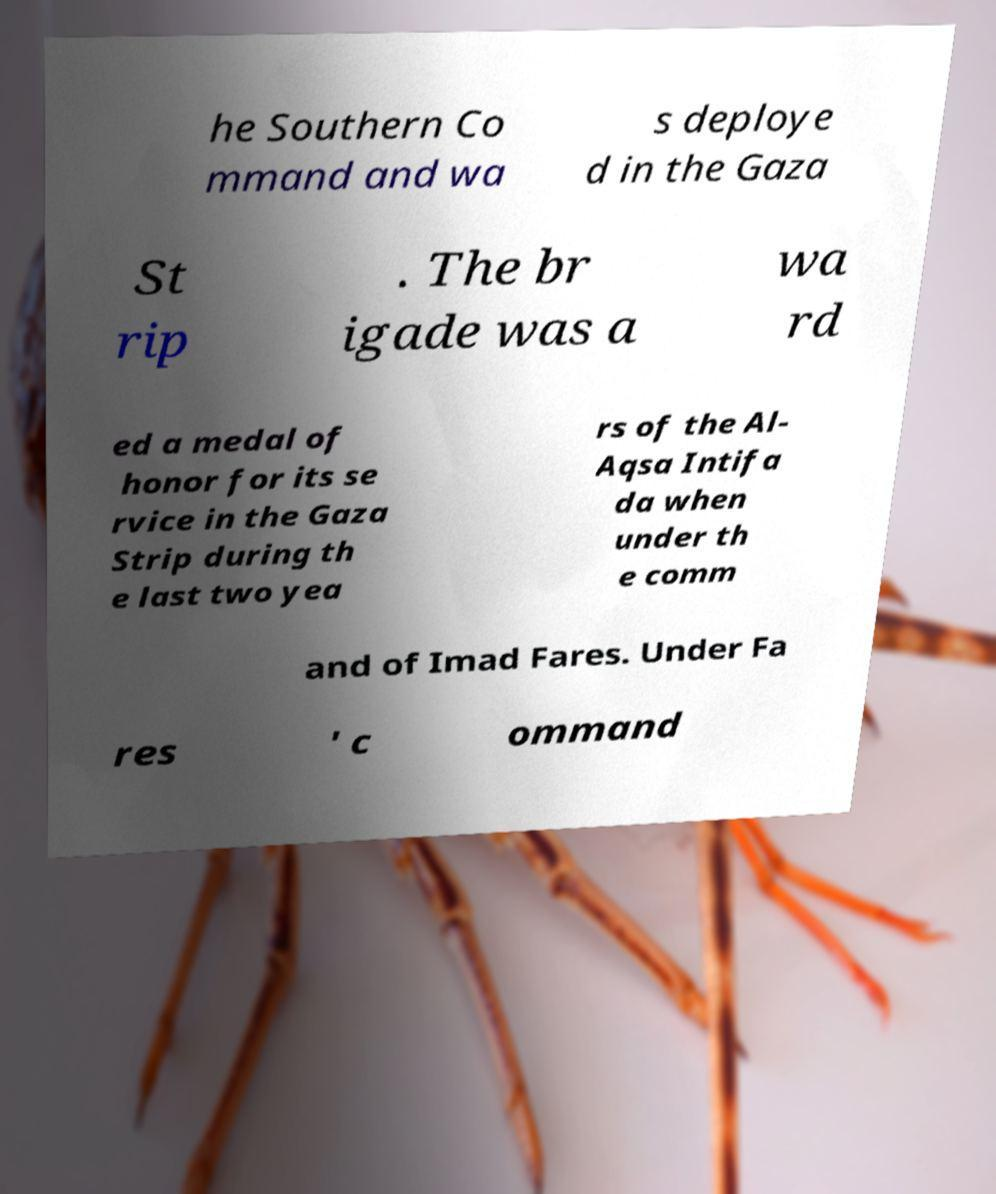There's text embedded in this image that I need extracted. Can you transcribe it verbatim? he Southern Co mmand and wa s deploye d in the Gaza St rip . The br igade was a wa rd ed a medal of honor for its se rvice in the Gaza Strip during th e last two yea rs of the Al- Aqsa Intifa da when under th e comm and of Imad Fares. Under Fa res ' c ommand 